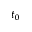Convert formula to latex. <formula><loc_0><loc_0><loc_500><loc_500>t _ { 0 }</formula> 